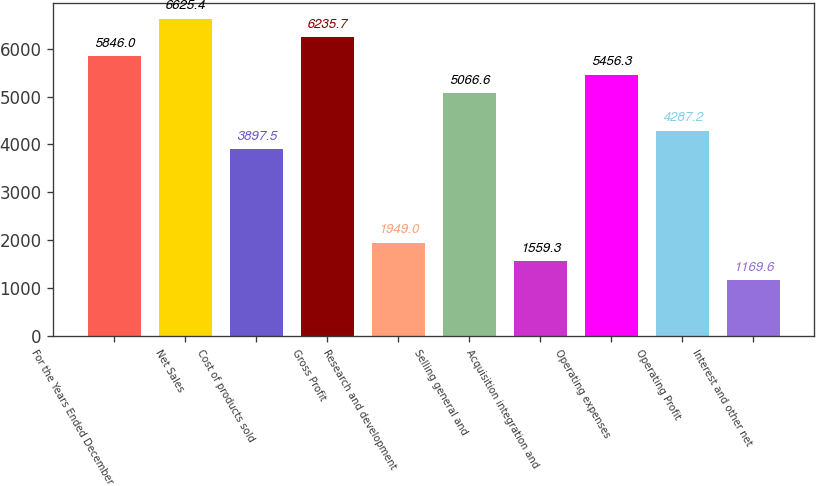<chart> <loc_0><loc_0><loc_500><loc_500><bar_chart><fcel>For the Years Ended December<fcel>Net Sales<fcel>Cost of products sold<fcel>Gross Profit<fcel>Research and development<fcel>Selling general and<fcel>Acquisition integration and<fcel>Operating expenses<fcel>Operating Profit<fcel>Interest and other net<nl><fcel>5846<fcel>6625.4<fcel>3897.5<fcel>6235.7<fcel>1949<fcel>5066.6<fcel>1559.3<fcel>5456.3<fcel>4287.2<fcel>1169.6<nl></chart> 